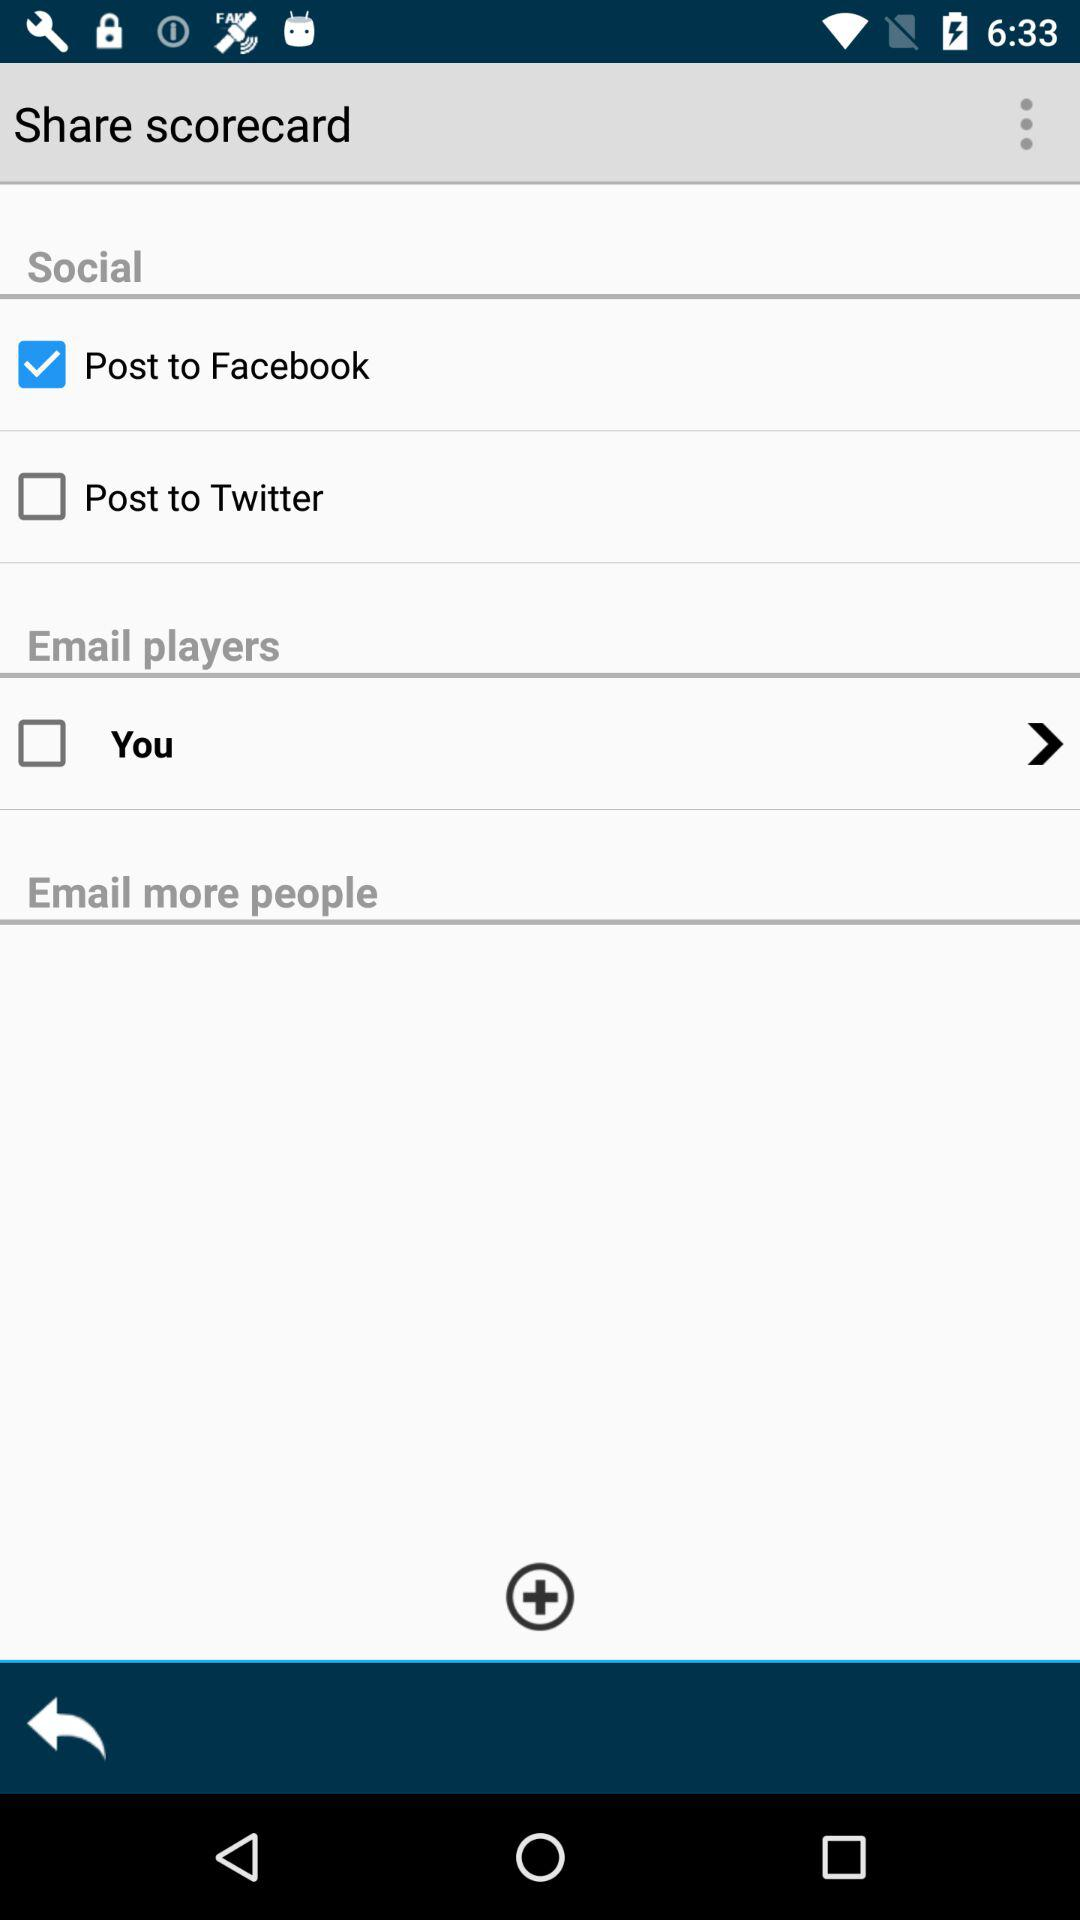What's the name of the accounts on which the content can be posted? The names of the accounts on which the content can be posted are "Facebook" and "Twitter". 